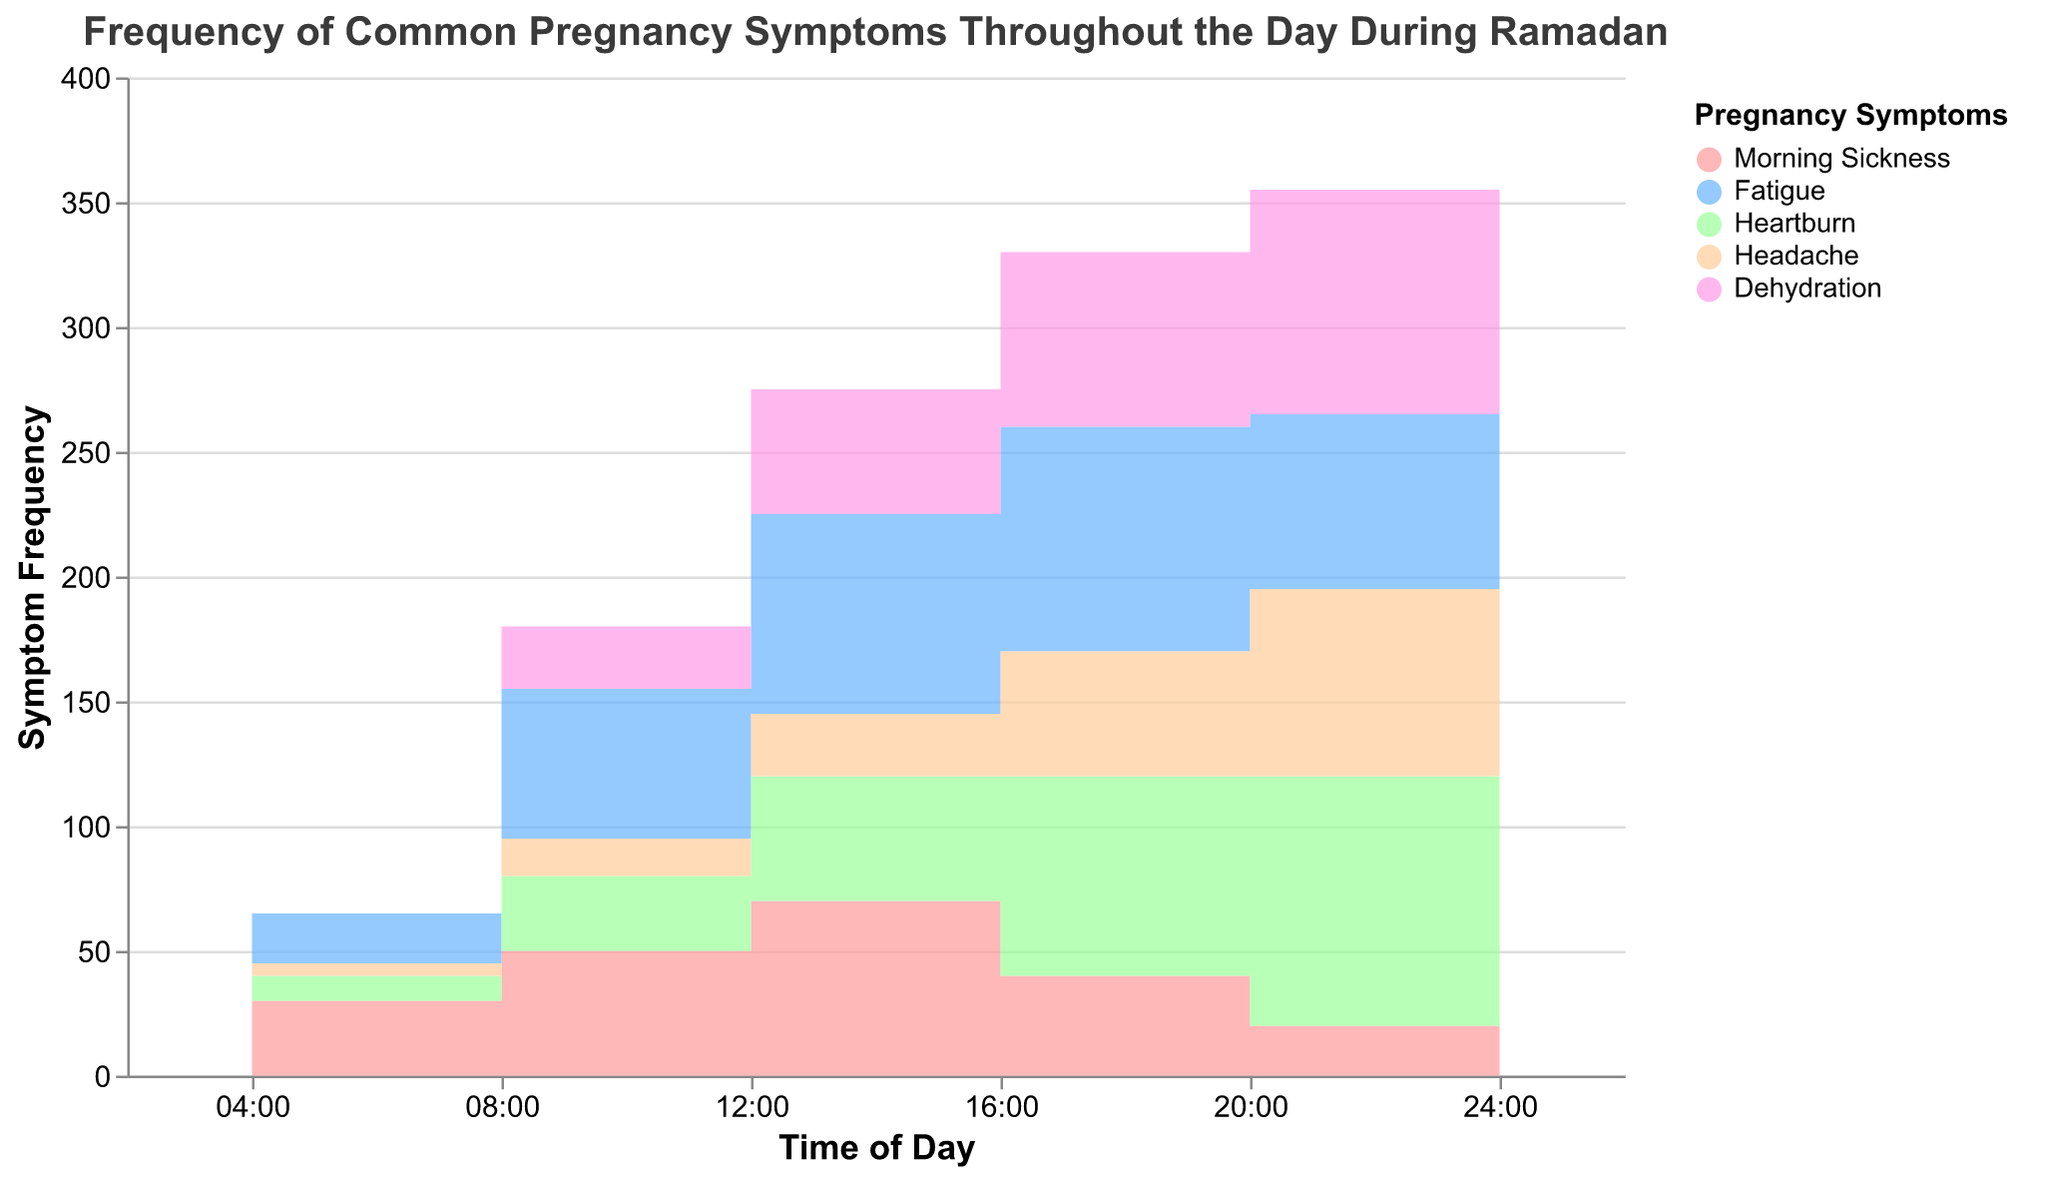When does morning sickness peak during the day? By looking at the step area chart, the frequency of morning sickness is highest at 12:00, as represented by the peak in the area marked for morning sickness.
Answer: 12:00 How does the frequency of dehydration change from 04:00 to 24:00? From 04:00 to 08:00, the dehydration frequency increases from 0 to 25. It continues rising to 50 at 12:00, reaches 70 at 16:00, peaks at 90 at 20:00, and slightly decreases to 60 at 24:00.
Answer: It generally increases but peaks at 20:00 and then decreases Which symptom has the highest frequency at 16:00? At 16:00, the step area chart shows that fatigue has a frequency of 90, which is the highest compared to other symptoms at that time.
Answer: Fatigue What is the average frequency of heartburn across all times shown? The frequencies of heartburn at each time point are 10, 30, 50, 80, 100, and 60. Adding these gives 330, and dividing by 6 (the number of time points) gives an average of 55.
Answer: 55 Which symptom shows the most significant increase in frequency between 08:00 and 12:00? To find the increase, subtract the frequency at 08:00 from the frequency at 12:00 for each symptom. Morning sickness: 70 - 50 = 20 Fatigue: 80 - 60 = 20 Heartburn: 50 - 30 = 20 Headache: 25 - 15 = 10 Dehydration: 50 - 25 = 25 Dehydration has the highest increase of 25.
Answer: Dehydration Are there any symptoms with similar frequency trends throughout the day? By observing the step area chart, morning sickness and headache frequencies both have peaks around midday and then decrease towards the evening and night.
Answer: Morning sickness and headache What is the difference in the frequency of fatigue between 04:00 and 16:00? At 04:00, the frequency of fatigue is 20. At 16:00, it is 90. The difference is calculated as 90 - 20.
Answer: 70 